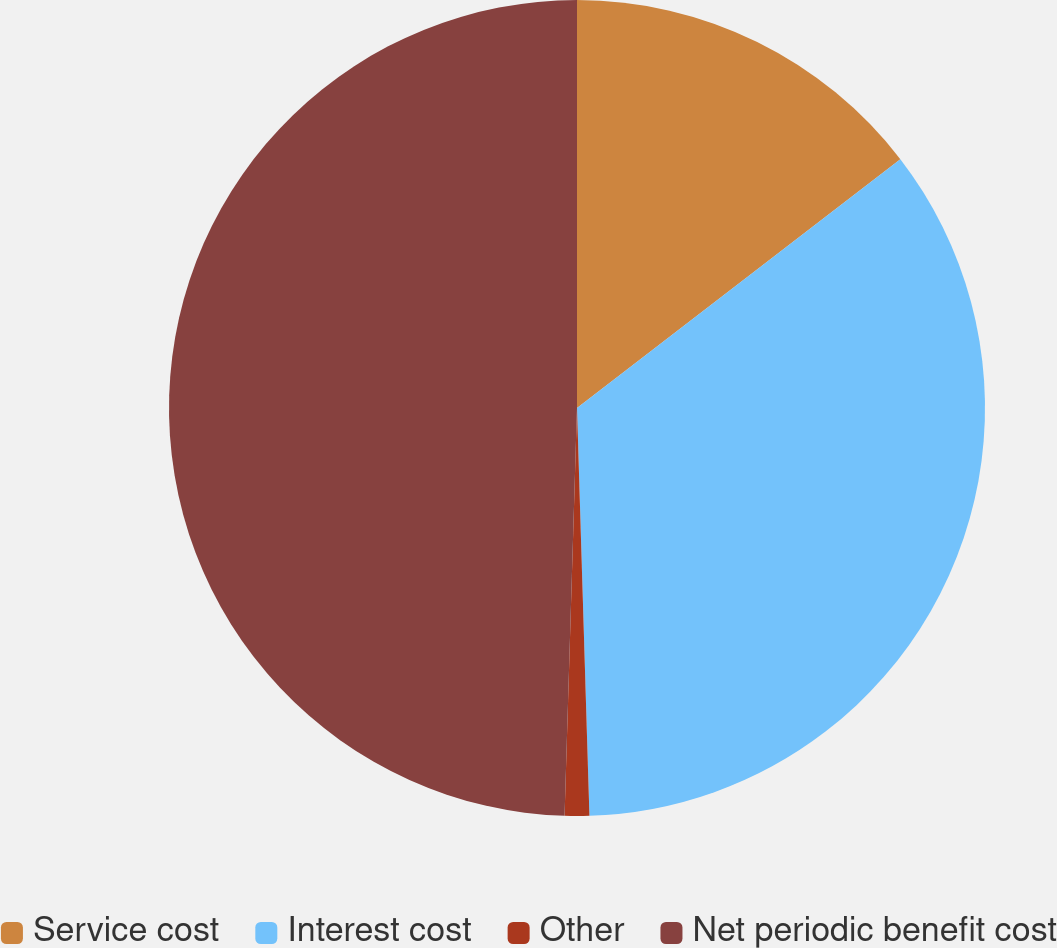<chart> <loc_0><loc_0><loc_500><loc_500><pie_chart><fcel>Service cost<fcel>Interest cost<fcel>Other<fcel>Net periodic benefit cost<nl><fcel>14.56%<fcel>34.95%<fcel>0.97%<fcel>49.51%<nl></chart> 